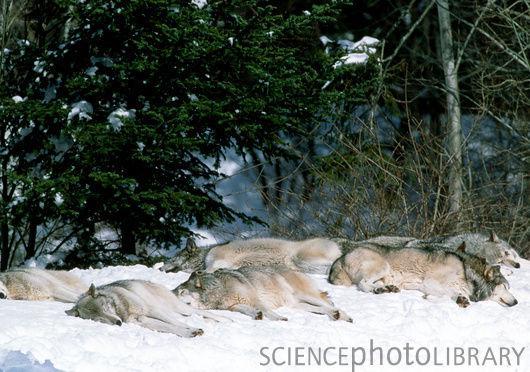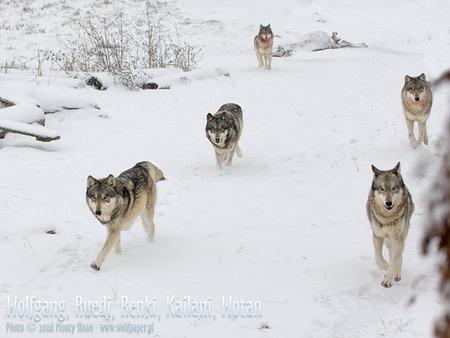The first image is the image on the left, the second image is the image on the right. Considering the images on both sides, is "There is a single dog in one image and multiple dogs in the other image." valid? Answer yes or no. No. The first image is the image on the left, the second image is the image on the right. Assess this claim about the two images: "There is only one wolf in one of the images.". Correct or not? Answer yes or no. No. 